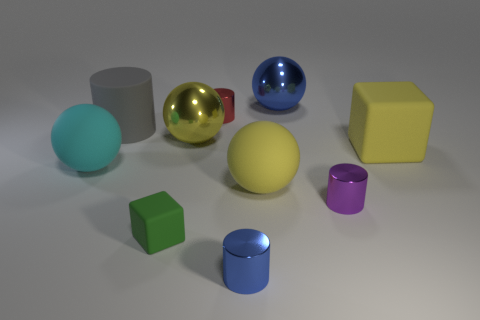Subtract all blue balls. How many balls are left? 3 Subtract all gray cylinders. How many yellow spheres are left? 2 Subtract all gray cylinders. How many cylinders are left? 3 Subtract all balls. How many objects are left? 6 Subtract 2 cylinders. How many cylinders are left? 2 Subtract all blue spheres. Subtract all brown cylinders. How many spheres are left? 3 Subtract all big yellow spheres. Subtract all small purple cylinders. How many objects are left? 7 Add 7 gray matte cylinders. How many gray matte cylinders are left? 8 Add 9 large yellow matte blocks. How many large yellow matte blocks exist? 10 Subtract 0 purple blocks. How many objects are left? 10 